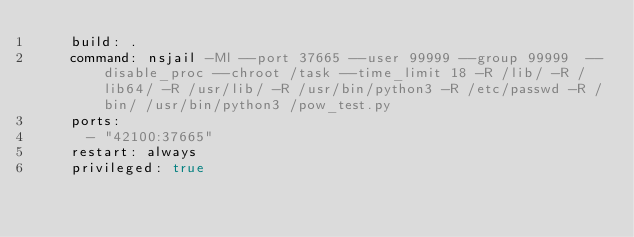Convert code to text. <code><loc_0><loc_0><loc_500><loc_500><_YAML_>    build: .
    command: nsjail -Ml --port 37665 --user 99999 --group 99999  --disable_proc --chroot /task --time_limit 18 -R /lib/ -R /lib64/ -R /usr/lib/ -R /usr/bin/python3 -R /etc/passwd -R /bin/ /usr/bin/python3 /pow_test.py
    ports:
      - "42100:37665"
    restart: always
    privileged: true
</code> 